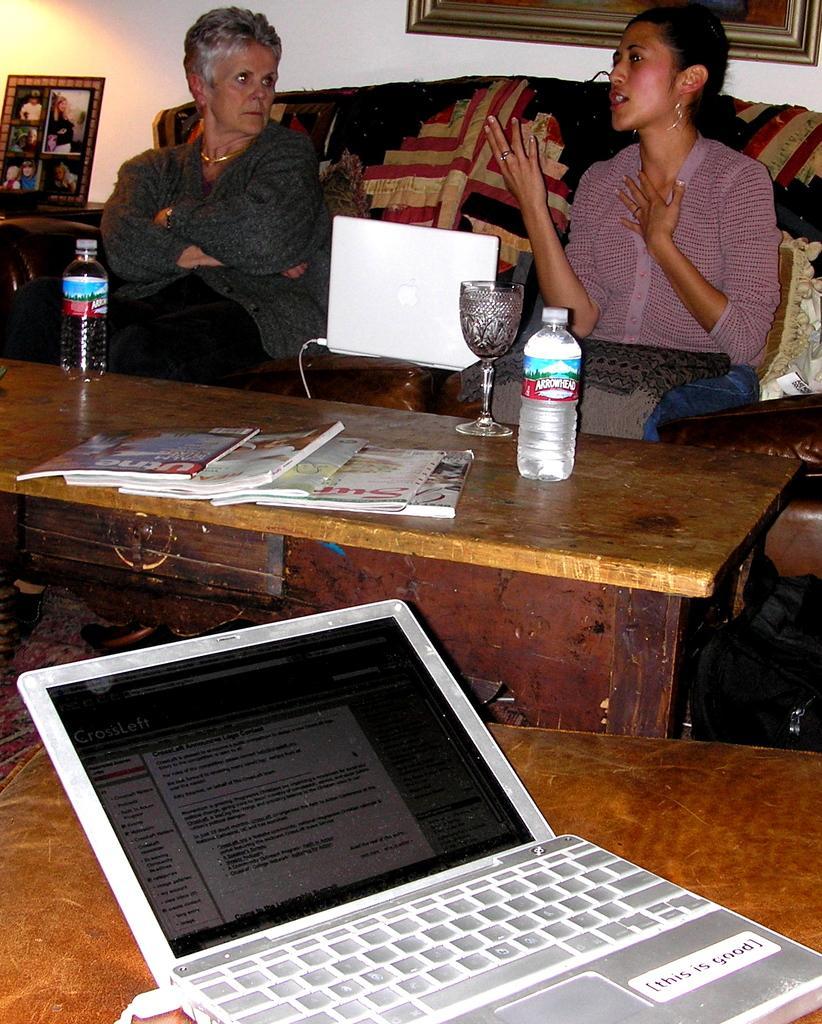Describe this image in one or two sentences. In this picture we can see two women are seated on the chair, in front of them we can see bottle, glass, books, laptop on the table. In the background there is a photo frame. 